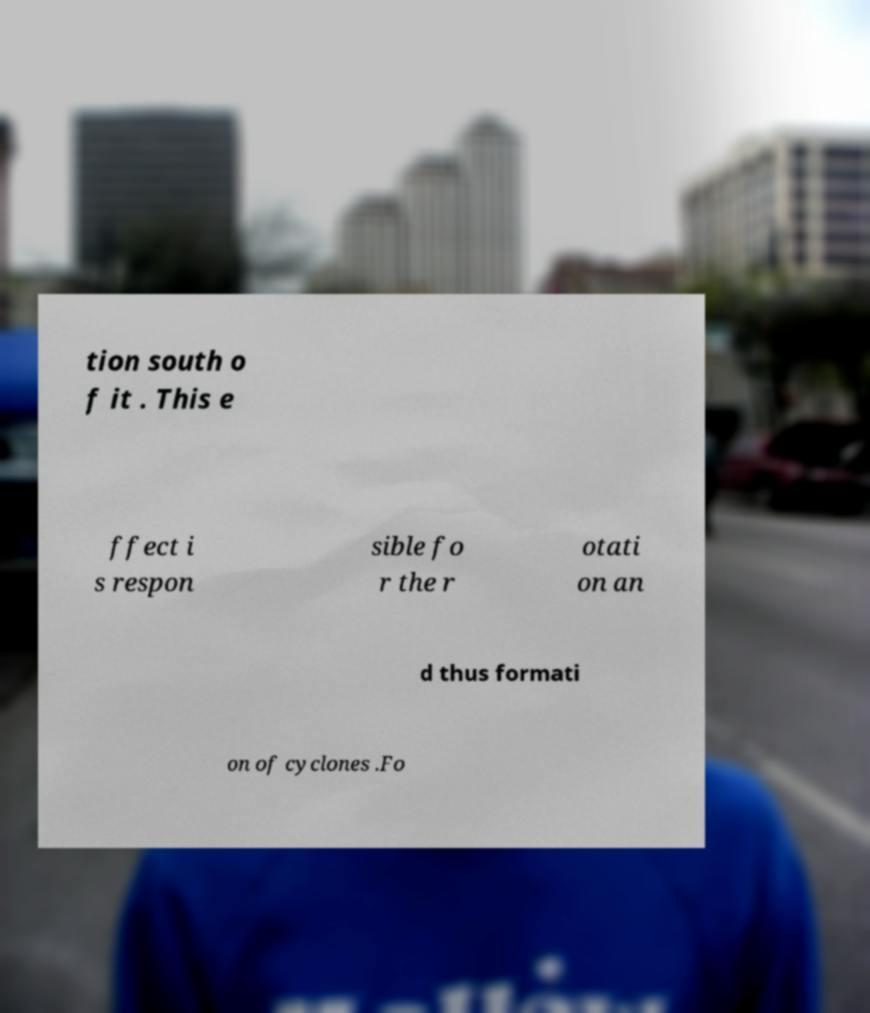What messages or text are displayed in this image? I need them in a readable, typed format. tion south o f it . This e ffect i s respon sible fo r the r otati on an d thus formati on of cyclones .Fo 